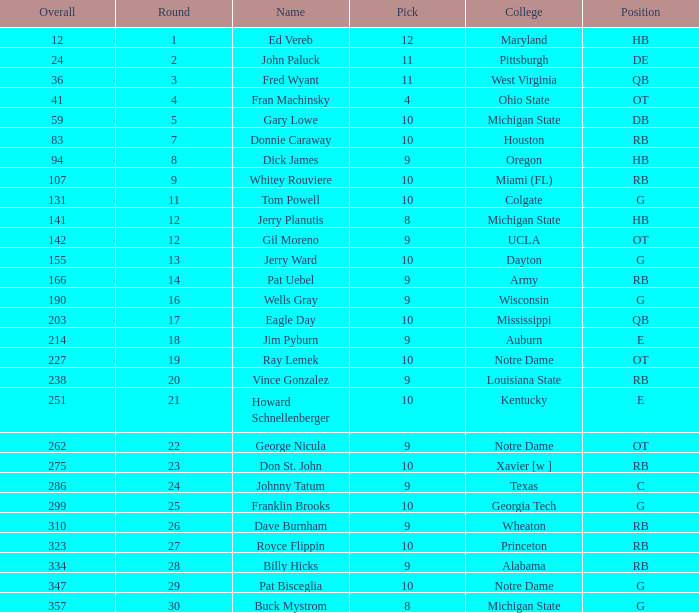What is the total number of overall picks that were after pick 9 and went to Auburn College? 0.0. 